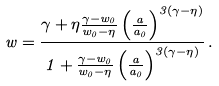Convert formula to latex. <formula><loc_0><loc_0><loc_500><loc_500>w = \frac { \gamma + \eta \frac { \gamma - w _ { 0 } } { w _ { 0 } - \eta } \left ( \frac { a } { a _ { 0 } } \right ) ^ { 3 ( \gamma - \eta ) } } { 1 + \frac { \gamma - w _ { 0 } } { w _ { 0 } - \eta } \left ( \frac { a } { a _ { 0 } } \right ) ^ { 3 ( \gamma - \eta ) } } \, .</formula> 